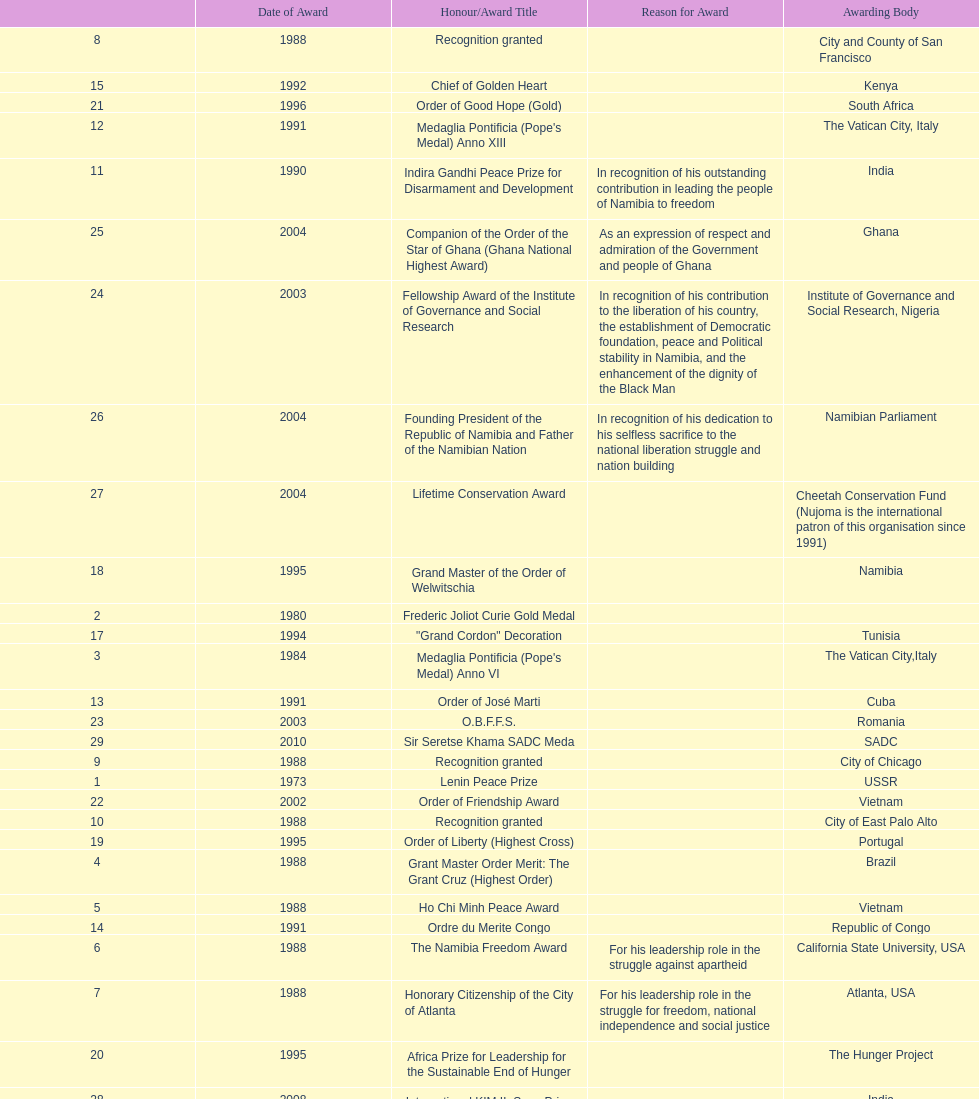I'm looking to parse the entire table for insights. Could you assist me with that? {'header': ['', 'Date of Award', 'Honour/Award Title', 'Reason for Award', 'Awarding Body'], 'rows': [['8', '1988', 'Recognition granted', '', 'City and County of San Francisco'], ['15', '1992', 'Chief of Golden Heart', '', 'Kenya'], ['21', '1996', 'Order of Good Hope (Gold)', '', 'South Africa'], ['12', '1991', "Medaglia Pontificia (Pope's Medal) Anno XIII", '', 'The Vatican City, Italy'], ['11', '1990', 'Indira Gandhi Peace Prize for Disarmament and Development', 'In recognition of his outstanding contribution in leading the people of Namibia to freedom', 'India'], ['25', '2004', 'Companion of the Order of the Star of Ghana (Ghana National Highest Award)', 'As an expression of respect and admiration of the Government and people of Ghana', 'Ghana'], ['24', '2003', 'Fellowship Award of the Institute of Governance and Social Research', 'In recognition of his contribution to the liberation of his country, the establishment of Democratic foundation, peace and Political stability in Namibia, and the enhancement of the dignity of the Black Man', 'Institute of Governance and Social Research, Nigeria'], ['26', '2004', 'Founding President of the Republic of Namibia and Father of the Namibian Nation', 'In recognition of his dedication to his selfless sacrifice to the national liberation struggle and nation building', 'Namibian Parliament'], ['27', '2004', 'Lifetime Conservation Award', '', 'Cheetah Conservation Fund (Nujoma is the international patron of this organisation since 1991)'], ['18', '1995', 'Grand Master of the Order of Welwitschia', '', 'Namibia'], ['2', '1980', 'Frederic Joliot Curie Gold Medal', '', ''], ['17', '1994', '"Grand Cordon" Decoration', '', 'Tunisia'], ['3', '1984', "Medaglia Pontificia (Pope's Medal) Anno VI", '', 'The Vatican City,Italy'], ['13', '1991', 'Order of José Marti', '', 'Cuba'], ['23', '2003', 'O.B.F.F.S.', '', 'Romania'], ['29', '2010', 'Sir Seretse Khama SADC Meda', '', 'SADC'], ['9', '1988', 'Recognition granted', '', 'City of Chicago'], ['1', '1973', 'Lenin Peace Prize', '', 'USSR'], ['22', '2002', 'Order of Friendship Award', '', 'Vietnam'], ['10', '1988', 'Recognition granted', '', 'City of East Palo Alto'], ['19', '1995', 'Order of Liberty (Highest Cross)', '', 'Portugal'], ['4', '1988', 'Grant Master Order Merit: The Grant Cruz (Highest Order)', '', 'Brazil'], ['5', '1988', 'Ho Chi Minh Peace Award', '', 'Vietnam'], ['14', '1991', 'Ordre du Merite Congo', '', 'Republic of Congo'], ['6', '1988', 'The Namibia Freedom Award', 'For his leadership role in the struggle against apartheid', 'California State University, USA'], ['7', '1988', 'Honorary Citizenship of the City of Atlanta', 'For his leadership role in the struggle for freedom, national independence and social justice', 'Atlanta, USA'], ['20', '1995', 'Africa Prize for Leadership for the Sustainable End of Hunger', '', 'The Hunger Project'], ['28', '2008', 'International KIM IL Sung Prize Certificate', '', 'India'], ['16', '1992', 'Order of the National Flag (First Class)', '', "Democratic People's Republic of Korea"]]} What is the most recent award nujoma received? Sir Seretse Khama SADC Meda. 